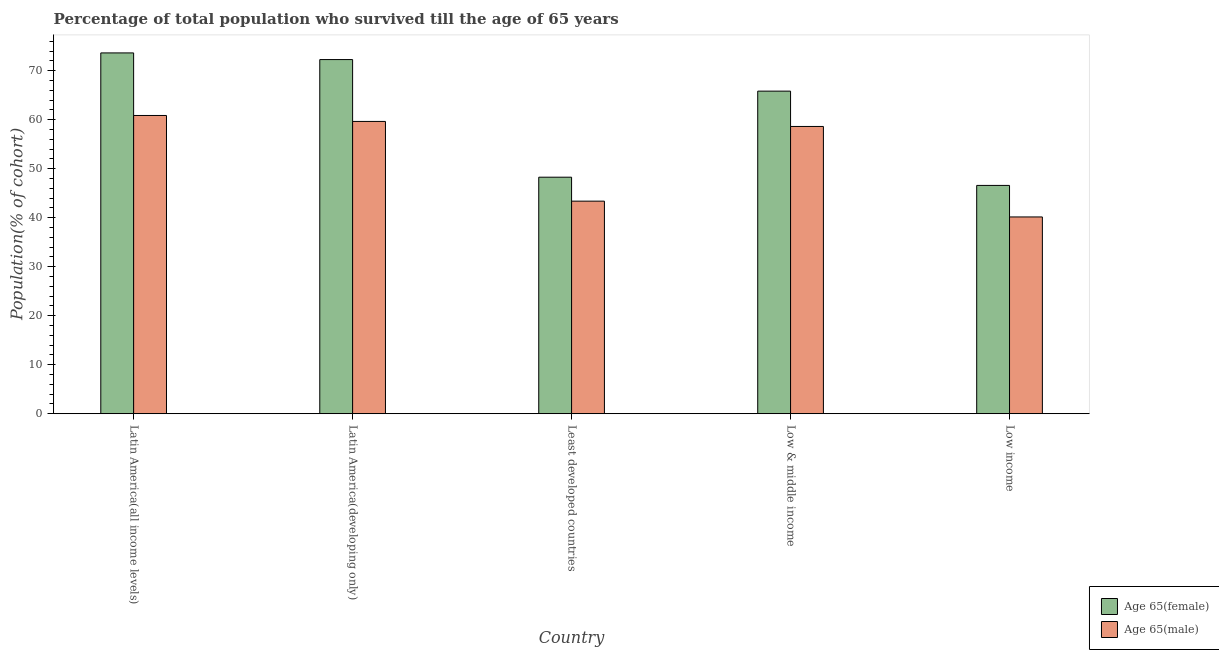How many groups of bars are there?
Give a very brief answer. 5. Are the number of bars per tick equal to the number of legend labels?
Provide a short and direct response. Yes. Are the number of bars on each tick of the X-axis equal?
Give a very brief answer. Yes. How many bars are there on the 3rd tick from the left?
Your response must be concise. 2. What is the percentage of female population who survived till age of 65 in Latin America(developing only)?
Provide a short and direct response. 72.26. Across all countries, what is the maximum percentage of female population who survived till age of 65?
Ensure brevity in your answer.  73.62. Across all countries, what is the minimum percentage of female population who survived till age of 65?
Keep it short and to the point. 46.59. In which country was the percentage of male population who survived till age of 65 maximum?
Your answer should be compact. Latin America(all income levels). In which country was the percentage of female population who survived till age of 65 minimum?
Give a very brief answer. Low income. What is the total percentage of male population who survived till age of 65 in the graph?
Offer a very short reply. 262.63. What is the difference between the percentage of female population who survived till age of 65 in Least developed countries and that in Low income?
Your response must be concise. 1.68. What is the difference between the percentage of female population who survived till age of 65 in Low income and the percentage of male population who survived till age of 65 in Least developed countries?
Offer a terse response. 3.21. What is the average percentage of female population who survived till age of 65 per country?
Make the answer very short. 61.31. What is the difference between the percentage of male population who survived till age of 65 and percentage of female population who survived till age of 65 in Latin America(all income levels)?
Your response must be concise. -12.76. In how many countries, is the percentage of male population who survived till age of 65 greater than 22 %?
Make the answer very short. 5. What is the ratio of the percentage of female population who survived till age of 65 in Latin America(developing only) to that in Low income?
Provide a short and direct response. 1.55. Is the percentage of male population who survived till age of 65 in Latin America(all income levels) less than that in Least developed countries?
Offer a terse response. No. Is the difference between the percentage of female population who survived till age of 65 in Latin America(developing only) and Low & middle income greater than the difference between the percentage of male population who survived till age of 65 in Latin America(developing only) and Low & middle income?
Your answer should be compact. Yes. What is the difference between the highest and the second highest percentage of male population who survived till age of 65?
Your answer should be compact. 1.22. What is the difference between the highest and the lowest percentage of female population who survived till age of 65?
Keep it short and to the point. 27.03. In how many countries, is the percentage of male population who survived till age of 65 greater than the average percentage of male population who survived till age of 65 taken over all countries?
Your answer should be very brief. 3. Is the sum of the percentage of male population who survived till age of 65 in Latin America(developing only) and Least developed countries greater than the maximum percentage of female population who survived till age of 65 across all countries?
Ensure brevity in your answer.  Yes. What does the 2nd bar from the left in Latin America(developing only) represents?
Offer a very short reply. Age 65(male). What does the 1st bar from the right in Latin America(developing only) represents?
Give a very brief answer. Age 65(male). How many bars are there?
Give a very brief answer. 10. Are all the bars in the graph horizontal?
Provide a short and direct response. No. How many countries are there in the graph?
Offer a very short reply. 5. Are the values on the major ticks of Y-axis written in scientific E-notation?
Your answer should be very brief. No. Does the graph contain grids?
Provide a succinct answer. No. How are the legend labels stacked?
Give a very brief answer. Vertical. What is the title of the graph?
Ensure brevity in your answer.  Percentage of total population who survived till the age of 65 years. Does "Goods" appear as one of the legend labels in the graph?
Offer a terse response. No. What is the label or title of the X-axis?
Provide a succinct answer. Country. What is the label or title of the Y-axis?
Provide a short and direct response. Population(% of cohort). What is the Population(% of cohort) in Age 65(female) in Latin America(all income levels)?
Provide a short and direct response. 73.62. What is the Population(% of cohort) in Age 65(male) in Latin America(all income levels)?
Your response must be concise. 60.86. What is the Population(% of cohort) in Age 65(female) in Latin America(developing only)?
Offer a very short reply. 72.26. What is the Population(% of cohort) in Age 65(male) in Latin America(developing only)?
Offer a terse response. 59.64. What is the Population(% of cohort) in Age 65(female) in Least developed countries?
Your answer should be compact. 48.26. What is the Population(% of cohort) in Age 65(male) in Least developed countries?
Make the answer very short. 43.37. What is the Population(% of cohort) in Age 65(female) in Low & middle income?
Your answer should be compact. 65.82. What is the Population(% of cohort) in Age 65(male) in Low & middle income?
Provide a succinct answer. 58.61. What is the Population(% of cohort) in Age 65(female) in Low income?
Give a very brief answer. 46.59. What is the Population(% of cohort) in Age 65(male) in Low income?
Provide a succinct answer. 40.15. Across all countries, what is the maximum Population(% of cohort) in Age 65(female)?
Your answer should be very brief. 73.62. Across all countries, what is the maximum Population(% of cohort) of Age 65(male)?
Give a very brief answer. 60.86. Across all countries, what is the minimum Population(% of cohort) in Age 65(female)?
Make the answer very short. 46.59. Across all countries, what is the minimum Population(% of cohort) in Age 65(male)?
Keep it short and to the point. 40.15. What is the total Population(% of cohort) of Age 65(female) in the graph?
Your answer should be very brief. 306.55. What is the total Population(% of cohort) in Age 65(male) in the graph?
Give a very brief answer. 262.63. What is the difference between the Population(% of cohort) in Age 65(female) in Latin America(all income levels) and that in Latin America(developing only)?
Keep it short and to the point. 1.36. What is the difference between the Population(% of cohort) in Age 65(male) in Latin America(all income levels) and that in Latin America(developing only)?
Give a very brief answer. 1.22. What is the difference between the Population(% of cohort) of Age 65(female) in Latin America(all income levels) and that in Least developed countries?
Your answer should be compact. 25.36. What is the difference between the Population(% of cohort) in Age 65(male) in Latin America(all income levels) and that in Least developed countries?
Your answer should be very brief. 17.48. What is the difference between the Population(% of cohort) of Age 65(female) in Latin America(all income levels) and that in Low & middle income?
Ensure brevity in your answer.  7.8. What is the difference between the Population(% of cohort) of Age 65(male) in Latin America(all income levels) and that in Low & middle income?
Offer a terse response. 2.24. What is the difference between the Population(% of cohort) of Age 65(female) in Latin America(all income levels) and that in Low income?
Your answer should be compact. 27.03. What is the difference between the Population(% of cohort) in Age 65(male) in Latin America(all income levels) and that in Low income?
Your answer should be compact. 20.7. What is the difference between the Population(% of cohort) of Age 65(female) in Latin America(developing only) and that in Least developed countries?
Make the answer very short. 24. What is the difference between the Population(% of cohort) of Age 65(male) in Latin America(developing only) and that in Least developed countries?
Ensure brevity in your answer.  16.27. What is the difference between the Population(% of cohort) in Age 65(female) in Latin America(developing only) and that in Low & middle income?
Provide a short and direct response. 6.44. What is the difference between the Population(% of cohort) of Age 65(male) in Latin America(developing only) and that in Low & middle income?
Offer a very short reply. 1.03. What is the difference between the Population(% of cohort) in Age 65(female) in Latin America(developing only) and that in Low income?
Give a very brief answer. 25.67. What is the difference between the Population(% of cohort) of Age 65(male) in Latin America(developing only) and that in Low income?
Make the answer very short. 19.49. What is the difference between the Population(% of cohort) of Age 65(female) in Least developed countries and that in Low & middle income?
Give a very brief answer. -17.56. What is the difference between the Population(% of cohort) in Age 65(male) in Least developed countries and that in Low & middle income?
Offer a terse response. -15.24. What is the difference between the Population(% of cohort) in Age 65(female) in Least developed countries and that in Low income?
Provide a short and direct response. 1.68. What is the difference between the Population(% of cohort) in Age 65(male) in Least developed countries and that in Low income?
Offer a very short reply. 3.22. What is the difference between the Population(% of cohort) in Age 65(female) in Low & middle income and that in Low income?
Ensure brevity in your answer.  19.23. What is the difference between the Population(% of cohort) of Age 65(male) in Low & middle income and that in Low income?
Ensure brevity in your answer.  18.46. What is the difference between the Population(% of cohort) of Age 65(female) in Latin America(all income levels) and the Population(% of cohort) of Age 65(male) in Latin America(developing only)?
Provide a short and direct response. 13.98. What is the difference between the Population(% of cohort) in Age 65(female) in Latin America(all income levels) and the Population(% of cohort) in Age 65(male) in Least developed countries?
Make the answer very short. 30.24. What is the difference between the Population(% of cohort) of Age 65(female) in Latin America(all income levels) and the Population(% of cohort) of Age 65(male) in Low & middle income?
Your answer should be very brief. 15.01. What is the difference between the Population(% of cohort) in Age 65(female) in Latin America(all income levels) and the Population(% of cohort) in Age 65(male) in Low income?
Offer a very short reply. 33.47. What is the difference between the Population(% of cohort) of Age 65(female) in Latin America(developing only) and the Population(% of cohort) of Age 65(male) in Least developed countries?
Offer a very short reply. 28.89. What is the difference between the Population(% of cohort) of Age 65(female) in Latin America(developing only) and the Population(% of cohort) of Age 65(male) in Low & middle income?
Your answer should be very brief. 13.65. What is the difference between the Population(% of cohort) in Age 65(female) in Latin America(developing only) and the Population(% of cohort) in Age 65(male) in Low income?
Offer a very short reply. 32.11. What is the difference between the Population(% of cohort) of Age 65(female) in Least developed countries and the Population(% of cohort) of Age 65(male) in Low & middle income?
Ensure brevity in your answer.  -10.35. What is the difference between the Population(% of cohort) of Age 65(female) in Least developed countries and the Population(% of cohort) of Age 65(male) in Low income?
Provide a short and direct response. 8.11. What is the difference between the Population(% of cohort) of Age 65(female) in Low & middle income and the Population(% of cohort) of Age 65(male) in Low income?
Offer a very short reply. 25.67. What is the average Population(% of cohort) in Age 65(female) per country?
Provide a short and direct response. 61.31. What is the average Population(% of cohort) of Age 65(male) per country?
Your answer should be compact. 52.53. What is the difference between the Population(% of cohort) in Age 65(female) and Population(% of cohort) in Age 65(male) in Latin America(all income levels)?
Your response must be concise. 12.76. What is the difference between the Population(% of cohort) of Age 65(female) and Population(% of cohort) of Age 65(male) in Latin America(developing only)?
Make the answer very short. 12.62. What is the difference between the Population(% of cohort) of Age 65(female) and Population(% of cohort) of Age 65(male) in Least developed countries?
Keep it short and to the point. 4.89. What is the difference between the Population(% of cohort) of Age 65(female) and Population(% of cohort) of Age 65(male) in Low & middle income?
Your response must be concise. 7.21. What is the difference between the Population(% of cohort) of Age 65(female) and Population(% of cohort) of Age 65(male) in Low income?
Provide a succinct answer. 6.43. What is the ratio of the Population(% of cohort) of Age 65(female) in Latin America(all income levels) to that in Latin America(developing only)?
Your response must be concise. 1.02. What is the ratio of the Population(% of cohort) in Age 65(male) in Latin America(all income levels) to that in Latin America(developing only)?
Provide a succinct answer. 1.02. What is the ratio of the Population(% of cohort) of Age 65(female) in Latin America(all income levels) to that in Least developed countries?
Provide a succinct answer. 1.53. What is the ratio of the Population(% of cohort) of Age 65(male) in Latin America(all income levels) to that in Least developed countries?
Offer a terse response. 1.4. What is the ratio of the Population(% of cohort) in Age 65(female) in Latin America(all income levels) to that in Low & middle income?
Your answer should be very brief. 1.12. What is the ratio of the Population(% of cohort) in Age 65(male) in Latin America(all income levels) to that in Low & middle income?
Ensure brevity in your answer.  1.04. What is the ratio of the Population(% of cohort) of Age 65(female) in Latin America(all income levels) to that in Low income?
Offer a very short reply. 1.58. What is the ratio of the Population(% of cohort) of Age 65(male) in Latin America(all income levels) to that in Low income?
Your answer should be compact. 1.52. What is the ratio of the Population(% of cohort) in Age 65(female) in Latin America(developing only) to that in Least developed countries?
Provide a succinct answer. 1.5. What is the ratio of the Population(% of cohort) in Age 65(male) in Latin America(developing only) to that in Least developed countries?
Keep it short and to the point. 1.38. What is the ratio of the Population(% of cohort) in Age 65(female) in Latin America(developing only) to that in Low & middle income?
Provide a succinct answer. 1.1. What is the ratio of the Population(% of cohort) in Age 65(male) in Latin America(developing only) to that in Low & middle income?
Ensure brevity in your answer.  1.02. What is the ratio of the Population(% of cohort) of Age 65(female) in Latin America(developing only) to that in Low income?
Provide a short and direct response. 1.55. What is the ratio of the Population(% of cohort) of Age 65(male) in Latin America(developing only) to that in Low income?
Your response must be concise. 1.49. What is the ratio of the Population(% of cohort) in Age 65(female) in Least developed countries to that in Low & middle income?
Your response must be concise. 0.73. What is the ratio of the Population(% of cohort) in Age 65(male) in Least developed countries to that in Low & middle income?
Ensure brevity in your answer.  0.74. What is the ratio of the Population(% of cohort) of Age 65(female) in Least developed countries to that in Low income?
Provide a succinct answer. 1.04. What is the ratio of the Population(% of cohort) of Age 65(male) in Least developed countries to that in Low income?
Provide a succinct answer. 1.08. What is the ratio of the Population(% of cohort) of Age 65(female) in Low & middle income to that in Low income?
Ensure brevity in your answer.  1.41. What is the ratio of the Population(% of cohort) in Age 65(male) in Low & middle income to that in Low income?
Your answer should be very brief. 1.46. What is the difference between the highest and the second highest Population(% of cohort) in Age 65(female)?
Your response must be concise. 1.36. What is the difference between the highest and the second highest Population(% of cohort) in Age 65(male)?
Keep it short and to the point. 1.22. What is the difference between the highest and the lowest Population(% of cohort) of Age 65(female)?
Your response must be concise. 27.03. What is the difference between the highest and the lowest Population(% of cohort) in Age 65(male)?
Offer a terse response. 20.7. 